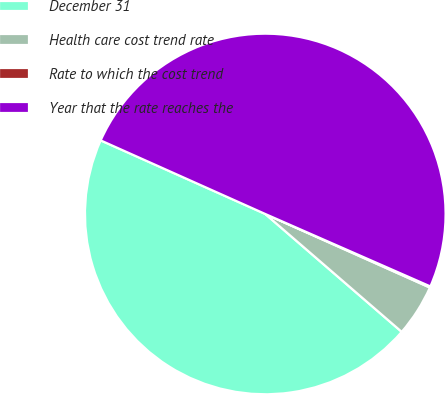Convert chart. <chart><loc_0><loc_0><loc_500><loc_500><pie_chart><fcel>December 31<fcel>Health care cost trend rate<fcel>Rate to which the cost trend<fcel>Year that the rate reaches the<nl><fcel>45.35%<fcel>4.65%<fcel>0.11%<fcel>49.89%<nl></chart> 